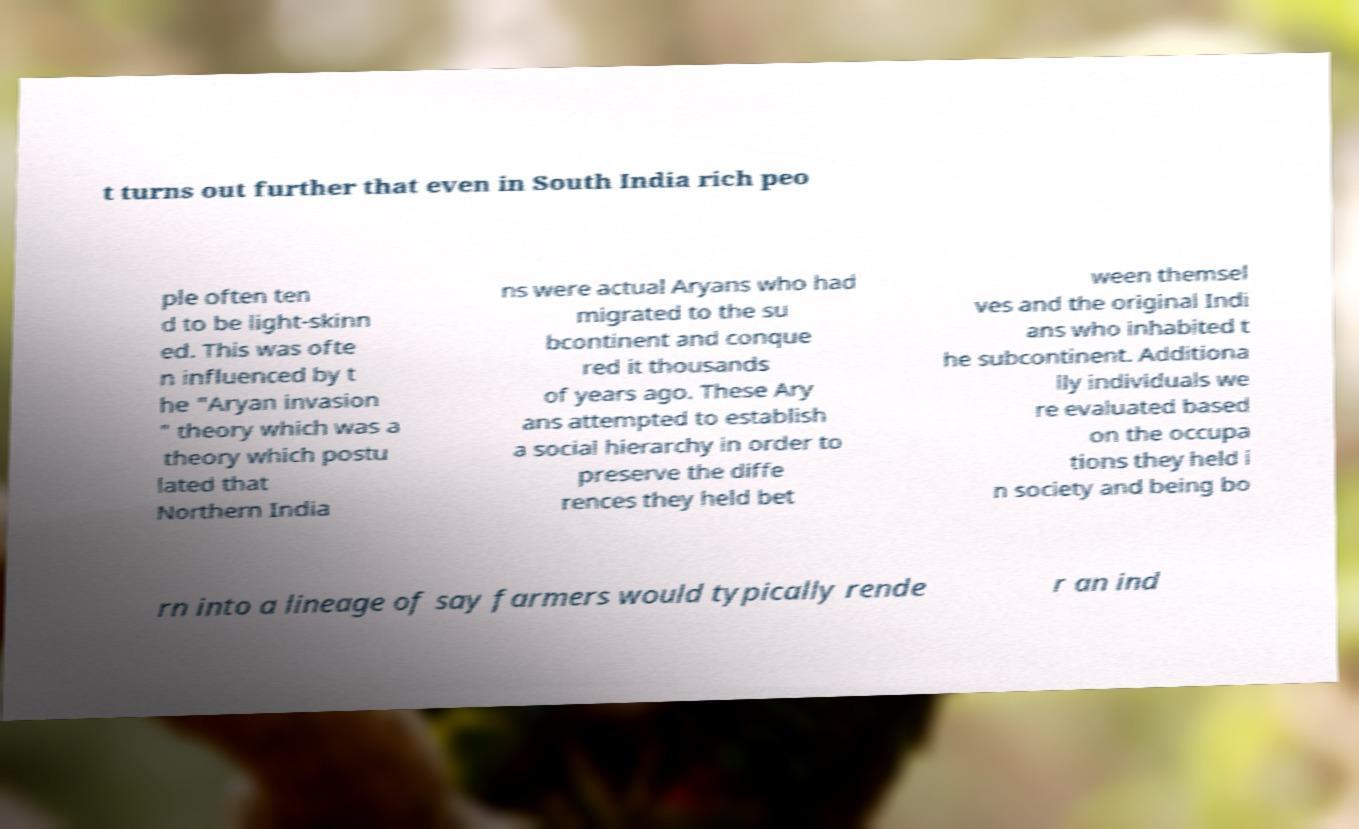Could you extract and type out the text from this image? t turns out further that even in South India rich peo ple often ten d to be light-skinn ed. This was ofte n influenced by t he "Aryan invasion " theory which was a theory which postu lated that Northern India ns were actual Aryans who had migrated to the su bcontinent and conque red it thousands of years ago. These Ary ans attempted to establish a social hierarchy in order to preserve the diffe rences they held bet ween themsel ves and the original Indi ans who inhabited t he subcontinent. Additiona lly individuals we re evaluated based on the occupa tions they held i n society and being bo rn into a lineage of say farmers would typically rende r an ind 